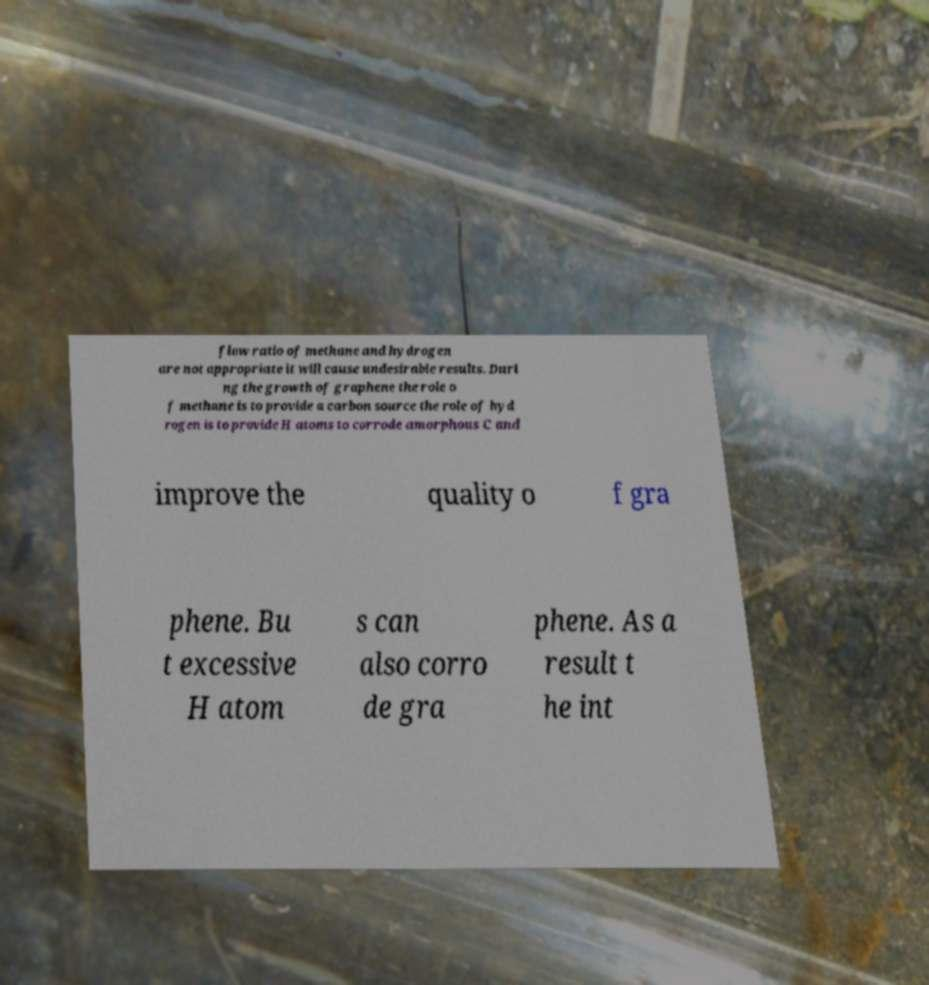Please read and relay the text visible in this image. What does it say? flow ratio of methane and hydrogen are not appropriate it will cause undesirable results. Duri ng the growth of graphene the role o f methane is to provide a carbon source the role of hyd rogen is to provide H atoms to corrode amorphous C and improve the quality o f gra phene. Bu t excessive H atom s can also corro de gra phene. As a result t he int 